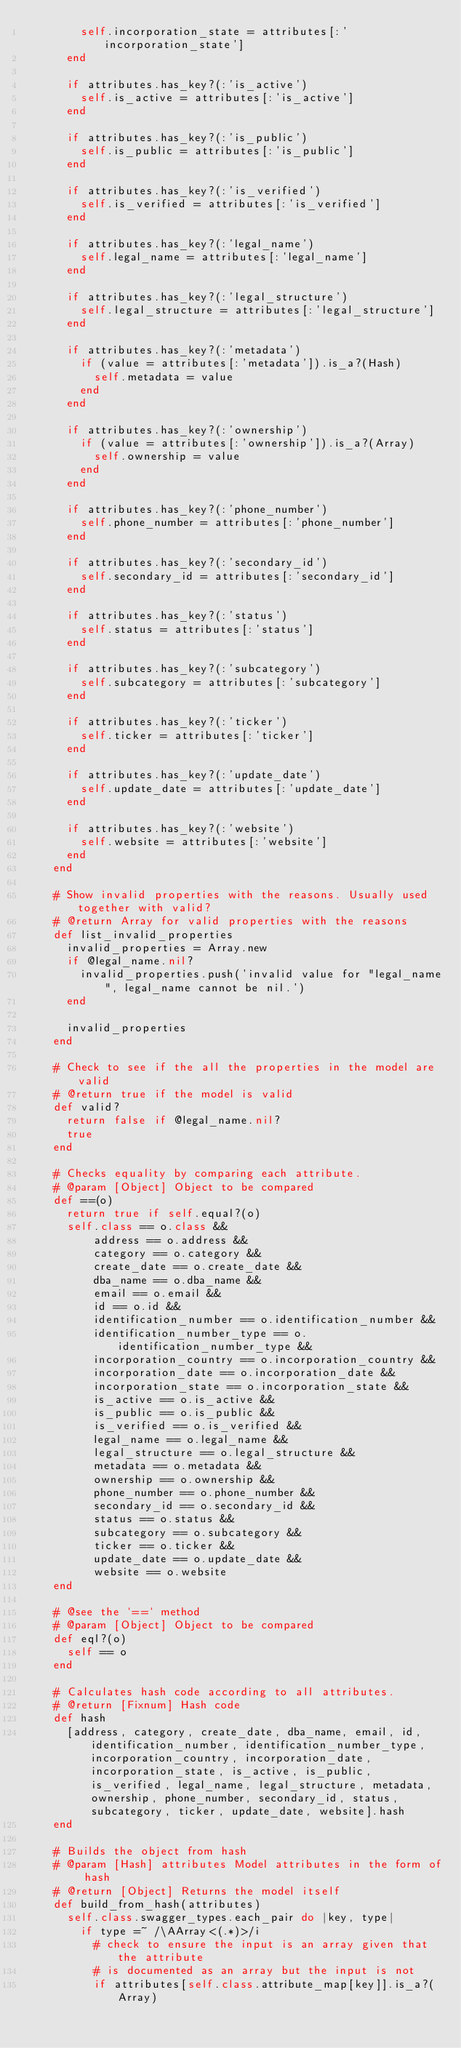Convert code to text. <code><loc_0><loc_0><loc_500><loc_500><_Ruby_>        self.incorporation_state = attributes[:'incorporation_state']
      end

      if attributes.has_key?(:'is_active')
        self.is_active = attributes[:'is_active']
      end

      if attributes.has_key?(:'is_public')
        self.is_public = attributes[:'is_public']
      end

      if attributes.has_key?(:'is_verified')
        self.is_verified = attributes[:'is_verified']
      end

      if attributes.has_key?(:'legal_name')
        self.legal_name = attributes[:'legal_name']
      end

      if attributes.has_key?(:'legal_structure')
        self.legal_structure = attributes[:'legal_structure']
      end

      if attributes.has_key?(:'metadata')
        if (value = attributes[:'metadata']).is_a?(Hash)
          self.metadata = value
        end
      end

      if attributes.has_key?(:'ownership')
        if (value = attributes[:'ownership']).is_a?(Array)
          self.ownership = value
        end
      end

      if attributes.has_key?(:'phone_number')
        self.phone_number = attributes[:'phone_number']
      end

      if attributes.has_key?(:'secondary_id')
        self.secondary_id = attributes[:'secondary_id']
      end

      if attributes.has_key?(:'status')
        self.status = attributes[:'status']
      end

      if attributes.has_key?(:'subcategory')
        self.subcategory = attributes[:'subcategory']
      end

      if attributes.has_key?(:'ticker')
        self.ticker = attributes[:'ticker']
      end

      if attributes.has_key?(:'update_date')
        self.update_date = attributes[:'update_date']
      end

      if attributes.has_key?(:'website')
        self.website = attributes[:'website']
      end
    end

    # Show invalid properties with the reasons. Usually used together with valid?
    # @return Array for valid properties with the reasons
    def list_invalid_properties
      invalid_properties = Array.new
      if @legal_name.nil?
        invalid_properties.push('invalid value for "legal_name", legal_name cannot be nil.')
      end

      invalid_properties
    end

    # Check to see if the all the properties in the model are valid
    # @return true if the model is valid
    def valid?
      return false if @legal_name.nil?
      true
    end

    # Checks equality by comparing each attribute.
    # @param [Object] Object to be compared
    def ==(o)
      return true if self.equal?(o)
      self.class == o.class &&
          address == o.address &&
          category == o.category &&
          create_date == o.create_date &&
          dba_name == o.dba_name &&
          email == o.email &&
          id == o.id &&
          identification_number == o.identification_number &&
          identification_number_type == o.identification_number_type &&
          incorporation_country == o.incorporation_country &&
          incorporation_date == o.incorporation_date &&
          incorporation_state == o.incorporation_state &&
          is_active == o.is_active &&
          is_public == o.is_public &&
          is_verified == o.is_verified &&
          legal_name == o.legal_name &&
          legal_structure == o.legal_structure &&
          metadata == o.metadata &&
          ownership == o.ownership &&
          phone_number == o.phone_number &&
          secondary_id == o.secondary_id &&
          status == o.status &&
          subcategory == o.subcategory &&
          ticker == o.ticker &&
          update_date == o.update_date &&
          website == o.website
    end

    # @see the `==` method
    # @param [Object] Object to be compared
    def eql?(o)
      self == o
    end

    # Calculates hash code according to all attributes.
    # @return [Fixnum] Hash code
    def hash
      [address, category, create_date, dba_name, email, id, identification_number, identification_number_type, incorporation_country, incorporation_date, incorporation_state, is_active, is_public, is_verified, legal_name, legal_structure, metadata, ownership, phone_number, secondary_id, status, subcategory, ticker, update_date, website].hash
    end

    # Builds the object from hash
    # @param [Hash] attributes Model attributes in the form of hash
    # @return [Object] Returns the model itself
    def build_from_hash(attributes)
      self.class.swagger_types.each_pair do |key, type|
        if type =~ /\AArray<(.*)>/i
          # check to ensure the input is an array given that the attribute
          # is documented as an array but the input is not
          if attributes[self.class.attribute_map[key]].is_a?(Array)</code> 